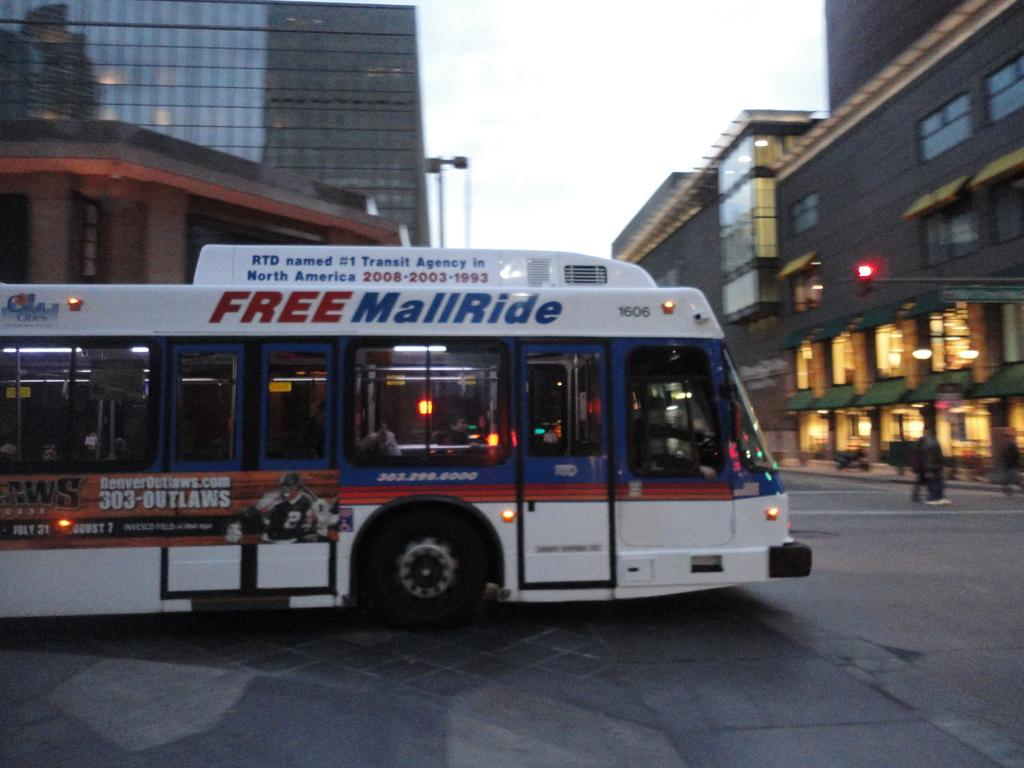What is the main subject in the center of the image? There is a bus in the center of the image. Where is the bus located? The bus is on the road. What can be seen in the background of the image? There are buildings and the sky visible in the background of the image. Are the same elements present on the right side of the image? Yes, the same elements (buildings and sky) are present to the right side of the image. What type of cake is being served on the bus in the image? There is no cake present in the image; it features a bus on the road with buildings and sky in the background. 